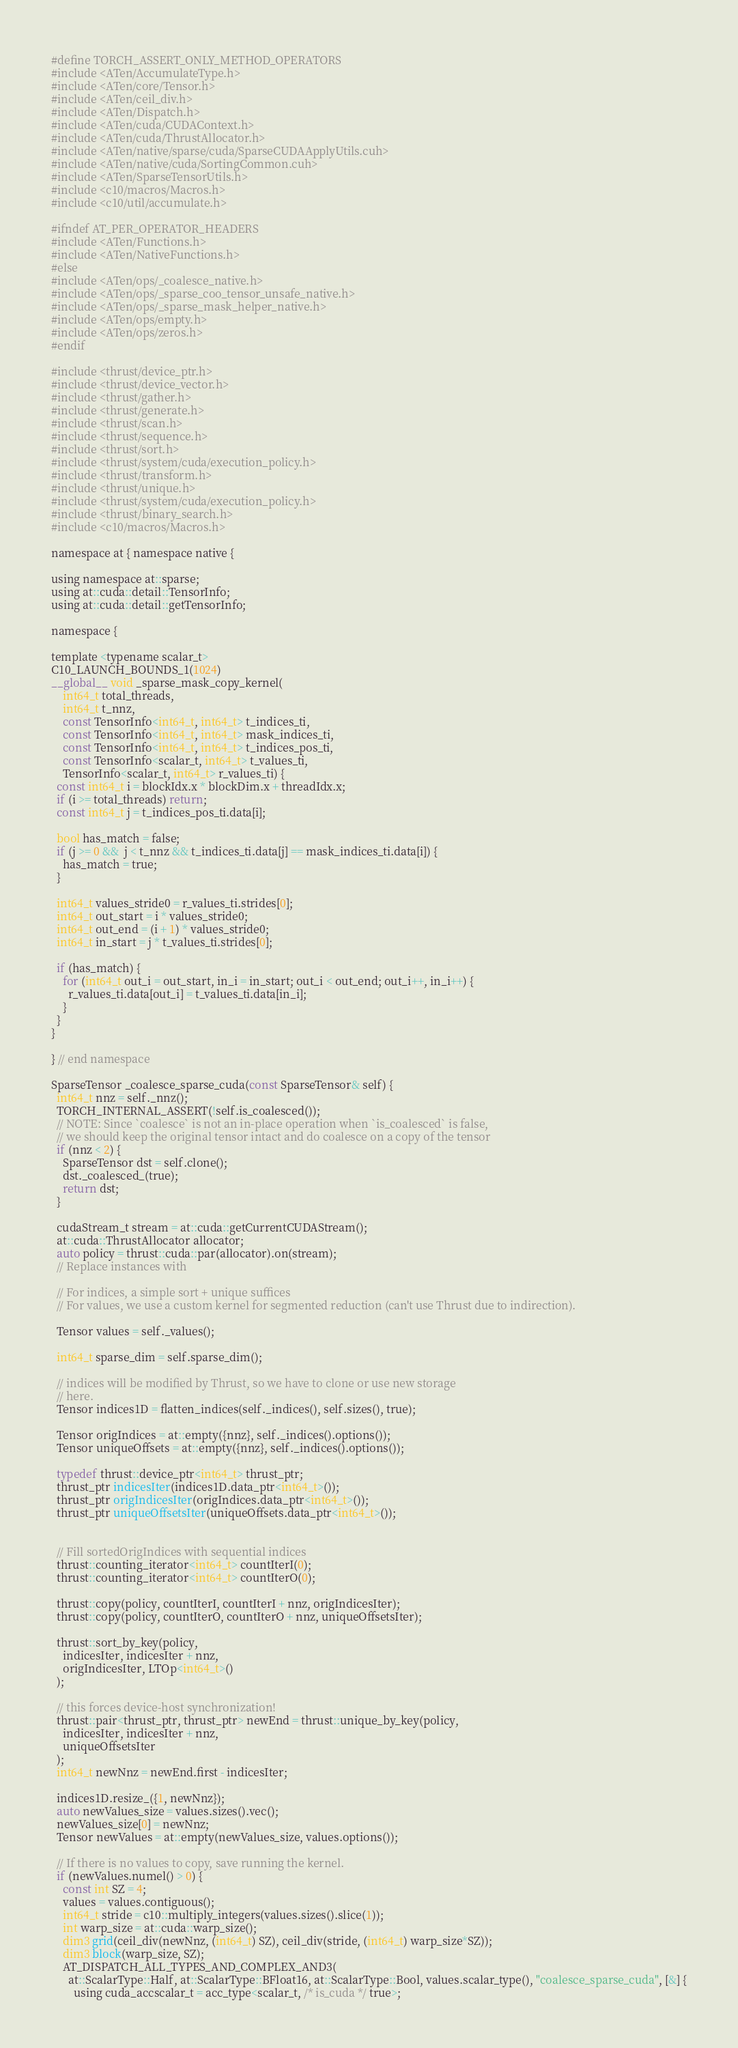<code> <loc_0><loc_0><loc_500><loc_500><_Cuda_>#define TORCH_ASSERT_ONLY_METHOD_OPERATORS
#include <ATen/AccumulateType.h>
#include <ATen/core/Tensor.h>
#include <ATen/ceil_div.h>
#include <ATen/Dispatch.h>
#include <ATen/cuda/CUDAContext.h>
#include <ATen/cuda/ThrustAllocator.h>
#include <ATen/native/sparse/cuda/SparseCUDAApplyUtils.cuh>
#include <ATen/native/cuda/SortingCommon.cuh>
#include <ATen/SparseTensorUtils.h>
#include <c10/macros/Macros.h>
#include <c10/util/accumulate.h>

#ifndef AT_PER_OPERATOR_HEADERS
#include <ATen/Functions.h>
#include <ATen/NativeFunctions.h>
#else
#include <ATen/ops/_coalesce_native.h>
#include <ATen/ops/_sparse_coo_tensor_unsafe_native.h>
#include <ATen/ops/_sparse_mask_helper_native.h>
#include <ATen/ops/empty.h>
#include <ATen/ops/zeros.h>
#endif

#include <thrust/device_ptr.h>
#include <thrust/device_vector.h>
#include <thrust/gather.h>
#include <thrust/generate.h>
#include <thrust/scan.h>
#include <thrust/sequence.h>
#include <thrust/sort.h>
#include <thrust/system/cuda/execution_policy.h>
#include <thrust/transform.h>
#include <thrust/unique.h>
#include <thrust/system/cuda/execution_policy.h>
#include <thrust/binary_search.h>
#include <c10/macros/Macros.h>

namespace at { namespace native {

using namespace at::sparse;
using at::cuda::detail::TensorInfo;
using at::cuda::detail::getTensorInfo;

namespace {

template <typename scalar_t>
C10_LAUNCH_BOUNDS_1(1024)
__global__ void _sparse_mask_copy_kernel(
    int64_t total_threads,
    int64_t t_nnz,
    const TensorInfo<int64_t, int64_t> t_indices_ti,
    const TensorInfo<int64_t, int64_t> mask_indices_ti,
    const TensorInfo<int64_t, int64_t> t_indices_pos_ti,
    const TensorInfo<scalar_t, int64_t> t_values_ti,
    TensorInfo<scalar_t, int64_t> r_values_ti) {
  const int64_t i = blockIdx.x * blockDim.x + threadIdx.x;
  if (i >= total_threads) return;
  const int64_t j = t_indices_pos_ti.data[i];

  bool has_match = false;
  if (j >= 0 &&  j < t_nnz && t_indices_ti.data[j] == mask_indices_ti.data[i]) {
    has_match = true;
  }

  int64_t values_stride0 = r_values_ti.strides[0];
  int64_t out_start = i * values_stride0;
  int64_t out_end = (i + 1) * values_stride0;
  int64_t in_start = j * t_values_ti.strides[0];

  if (has_match) {
    for (int64_t out_i = out_start, in_i = in_start; out_i < out_end; out_i++, in_i++) {
      r_values_ti.data[out_i] = t_values_ti.data[in_i];
    }
  }
}

} // end namespace

SparseTensor _coalesce_sparse_cuda(const SparseTensor& self) {
  int64_t nnz = self._nnz();
  TORCH_INTERNAL_ASSERT(!self.is_coalesced());
  // NOTE: Since `coalesce` is not an in-place operation when `is_coalesced` is false,
  // we should keep the original tensor intact and do coalesce on a copy of the tensor
  if (nnz < 2) {
    SparseTensor dst = self.clone();
    dst._coalesced_(true);
    return dst;
  }

  cudaStream_t stream = at::cuda::getCurrentCUDAStream();
  at::cuda::ThrustAllocator allocator;
  auto policy = thrust::cuda::par(allocator).on(stream);
  // Replace instances with

  // For indices, a simple sort + unique suffices
  // For values, we use a custom kernel for segmented reduction (can't use Thrust due to indirection).

  Tensor values = self._values();

  int64_t sparse_dim = self.sparse_dim();

  // indices will be modified by Thrust, so we have to clone or use new storage
  // here.
  Tensor indices1D = flatten_indices(self._indices(), self.sizes(), true);

  Tensor origIndices = at::empty({nnz}, self._indices().options());
  Tensor uniqueOffsets = at::empty({nnz}, self._indices().options());

  typedef thrust::device_ptr<int64_t> thrust_ptr;
  thrust_ptr indicesIter(indices1D.data_ptr<int64_t>());
  thrust_ptr origIndicesIter(origIndices.data_ptr<int64_t>());
  thrust_ptr uniqueOffsetsIter(uniqueOffsets.data_ptr<int64_t>());


  // Fill sortedOrigIndices with sequential indices
  thrust::counting_iterator<int64_t> countIterI(0);
  thrust::counting_iterator<int64_t> countIterO(0);

  thrust::copy(policy, countIterI, countIterI + nnz, origIndicesIter);
  thrust::copy(policy, countIterO, countIterO + nnz, uniqueOffsetsIter);

  thrust::sort_by_key(policy,
    indicesIter, indicesIter + nnz,
    origIndicesIter, LTOp<int64_t>()
  );

  // this forces device-host synchronization!
  thrust::pair<thrust_ptr, thrust_ptr> newEnd = thrust::unique_by_key(policy,
    indicesIter, indicesIter + nnz,
    uniqueOffsetsIter
  );
  int64_t newNnz = newEnd.first - indicesIter;

  indices1D.resize_({1, newNnz});
  auto newValues_size = values.sizes().vec();
  newValues_size[0] = newNnz;
  Tensor newValues = at::empty(newValues_size, values.options());

  // If there is no values to copy, save running the kernel.
  if (newValues.numel() > 0) {
    const int SZ = 4;
    values = values.contiguous();
    int64_t stride = c10::multiply_integers(values.sizes().slice(1));
    int warp_size = at::cuda::warp_size();
    dim3 grid(ceil_div(newNnz, (int64_t) SZ), ceil_div(stride, (int64_t) warp_size*SZ));
    dim3 block(warp_size, SZ);
    AT_DISPATCH_ALL_TYPES_AND_COMPLEX_AND3(
      at::ScalarType::Half, at::ScalarType::BFloat16, at::ScalarType::Bool, values.scalar_type(), "coalesce_sparse_cuda", [&] {
        using cuda_accscalar_t = acc_type<scalar_t, /* is_cuda */ true>;</code> 